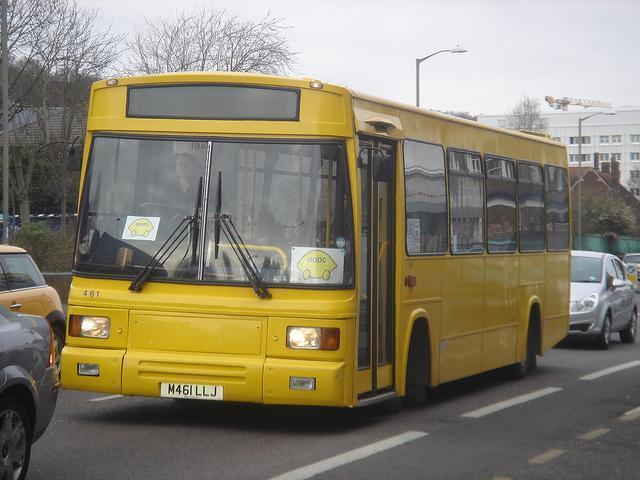How many buses are on the road?
Give a very brief answer. 1. How many cars are in the photo?
Give a very brief answer. 3. How many pink donuts are there?
Give a very brief answer. 0. 